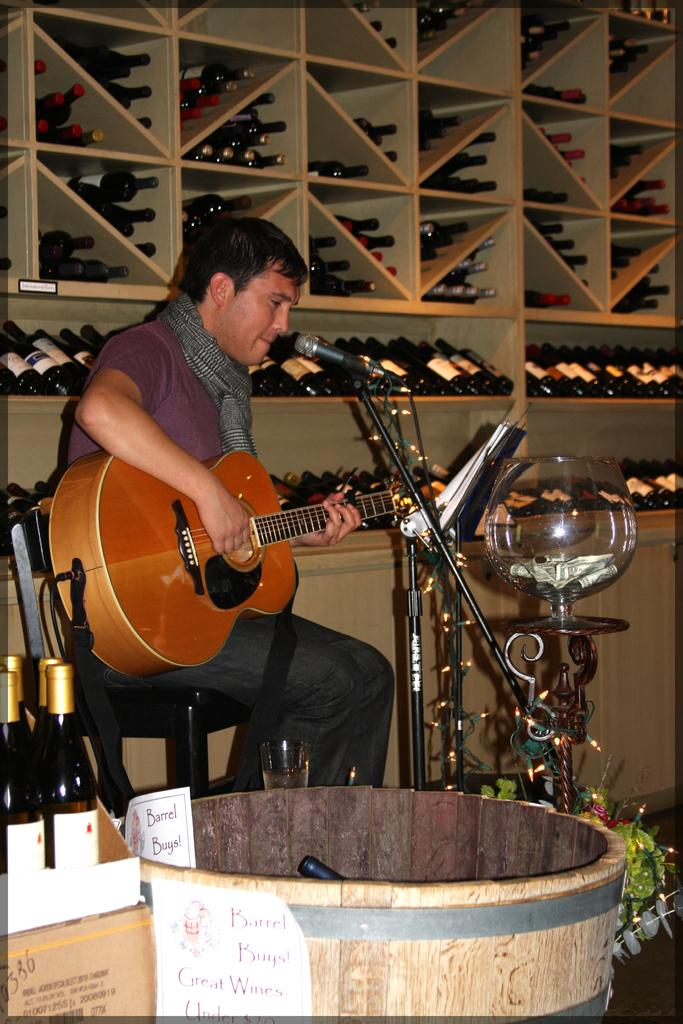Who is the main subject in the image? There is a man in the image. What is the man doing in the image? The man is sitting on a chair and playing a guitar. What object is in front of the man? There is a microphone in front of the man. Does the man have a pet in the image? There is no pet visible in the image. 